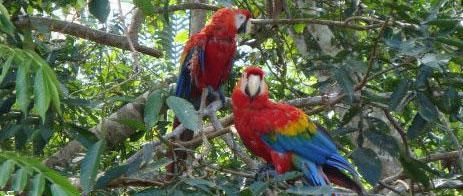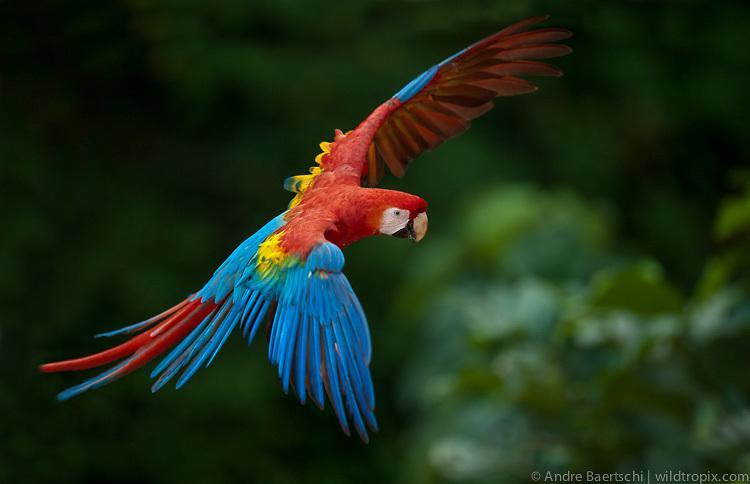The first image is the image on the left, the second image is the image on the right. Considering the images on both sides, is "At least one image contains a macaw in flight." valid? Answer yes or no. Yes. 